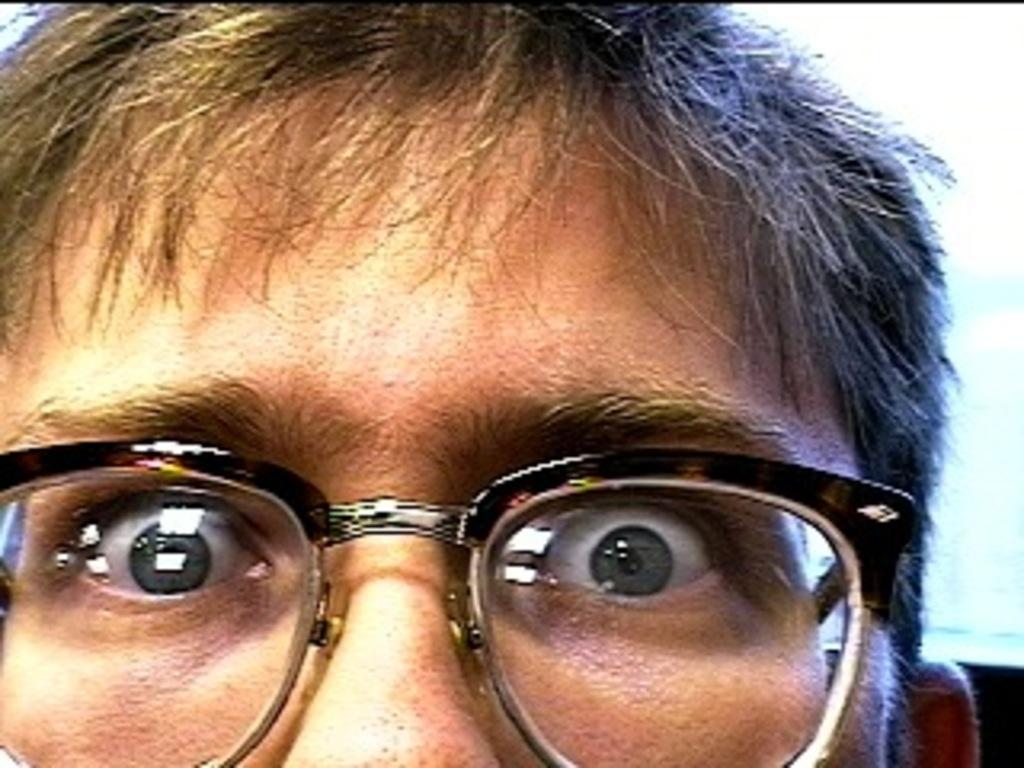Please provide a concise description of this image. This is a zoomed image. In this image we can see the face of a person. 